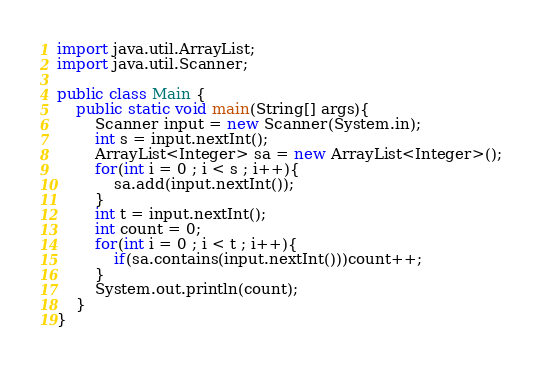Convert code to text. <code><loc_0><loc_0><loc_500><loc_500><_Java_>import java.util.ArrayList;
import java.util.Scanner;

public class Main {
    public static void main(String[] args){
    	Scanner input = new Scanner(System.in);
    	int s = input.nextInt();
    	ArrayList<Integer> sa = new ArrayList<Integer>();
    	for(int i = 0 ; i < s ; i++){
    		sa.add(input.nextInt());
    	}
    	int t = input.nextInt();
    	int count = 0;
    	for(int i = 0 ; i < t ; i++){
    		if(sa.contains(input.nextInt()))count++;
    	}
    	System.out.println(count);
    }
}</code> 